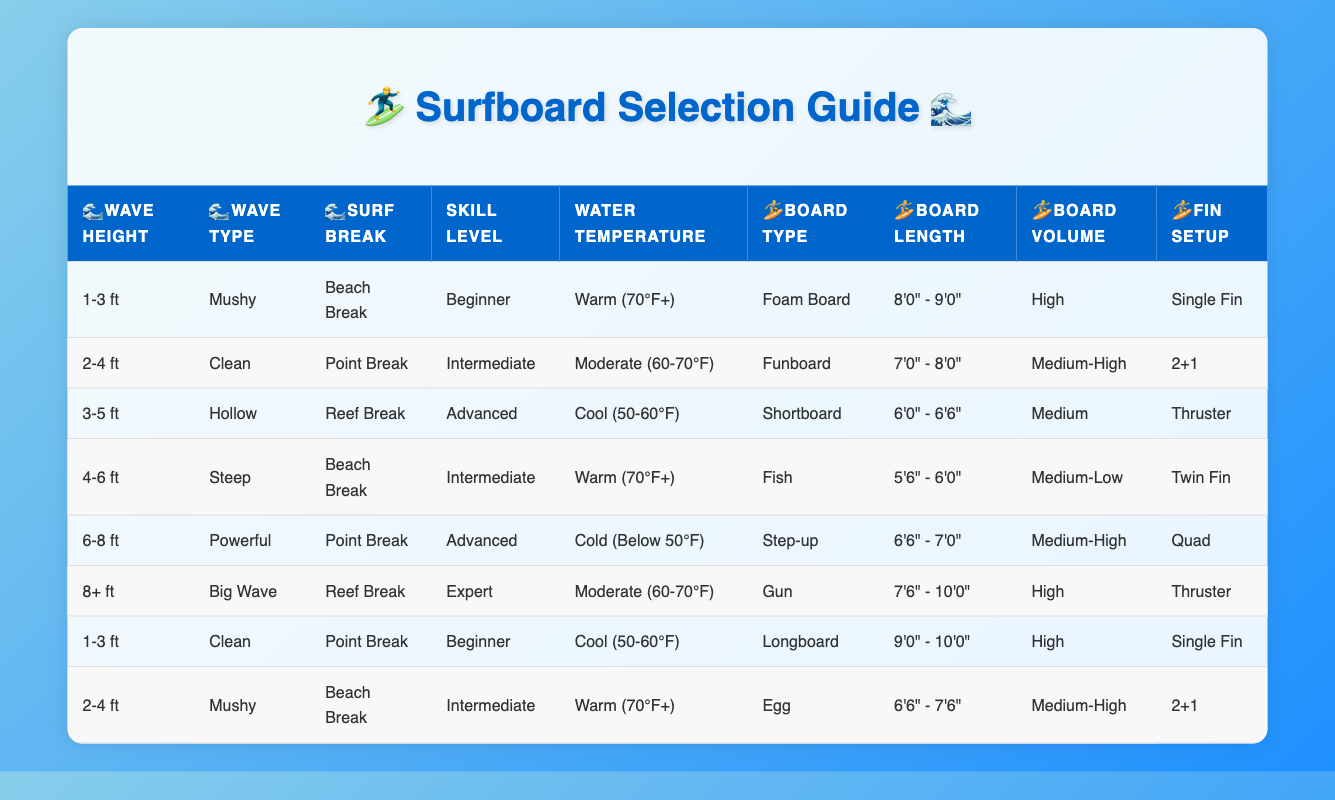What type of board is suitable for beginner surfers in warm water with mushy waves around 1-3 ft? Looking at the table, under the row matching the conditions of "1-3 ft" for wave height, "Mushy" for wave type, "Beach Break" for surf break, and "Beginner" for skill level, the board type specified is "Foam Board".
Answer: Foam Board What is the board volume for an advanced surfer expecting hollow waves at a reef break? The row for "3-5 ft" wave height with "Hollow" wave type and "Reef Break" surf break indicates that the board volume is "Medium".
Answer: Medium How many of the listed boards have a fin setup of "Single Fin"? By checking the table, there are two rows with "Single Fin" related to the board type: one under "Foam Board" for beginners and another under "Longboard" for also a beginner. Therefore, there are two entries with that setup.
Answer: 2 Which type of board is recommended for an expert in big wave conditions over 8 ft? The table contains a row with "8+ ft" for wave height, "Big Wave" for wave type, and "Reef Break" for surf break, indicating that the recommended board type is "Gun".
Answer: Gun If an intermediate surfer wants to ride 2-4 ft mushy waves at a beach break, what board volume should they expect? The row with "2-4 ft" for wave height and "Mushy" for wave type shows that a surfer with an intermediate skill level should consider a board volume of "Medium-High".
Answer: Medium-High Is there any board type that is suggested for cool water below 50°F? Checking the entries in the table, the row for "6-8 ft" waves states that the recommended board type under cool conditions is "Step-up". Hence, there is a board type suggested for that temperature category.
Answer: Yes What are the board lengths recommended for a fish board suited to intermediate surfers on steep waves at a beach break? For the "4-6 ft" condition with "Steep" waves and "Beach Break," the table indicates that the board length should be between "5'6" - 6'0"".
Answer: 5'6" - 6'0" Which fin setup is associated with the Gun board for expert surfers in moderate water temperatures? Referring to the "8+ ft" conditions with a "Big Wave" type for experts, the fin setup listed is "Thruster."
Answer: Thruster What is the average board length for all boards suitable for beginners? For beginners, we have two types of boards listed: 8'0" - 9'0" (Foam Board) and 9'0" - 10'0" (Longboard). To find the average length, we take (8.5 + 9.5)/2 = 9.0 feet.
Answer: 9.0 feet 